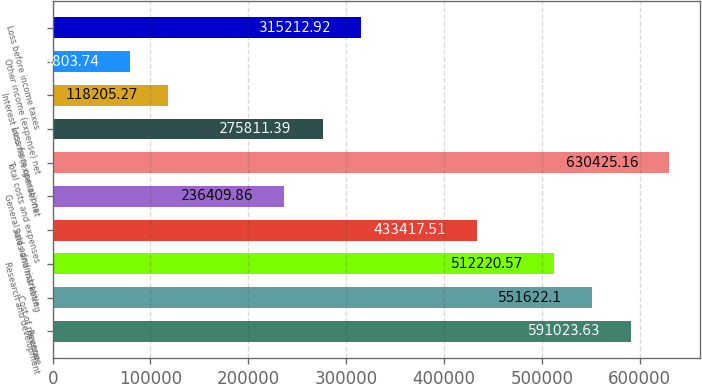<chart> <loc_0><loc_0><loc_500><loc_500><bar_chart><fcel>Revenue<fcel>Cost of revenue<fcel>Research and development<fcel>Sales and marketing<fcel>General and administrative<fcel>Total costs and expenses<fcel>Loss from operations<fcel>Interest income (expense) net<fcel>Other income (expense) net<fcel>Loss before income taxes<nl><fcel>591024<fcel>551622<fcel>512221<fcel>433418<fcel>236410<fcel>630425<fcel>275811<fcel>118205<fcel>78803.7<fcel>315213<nl></chart> 